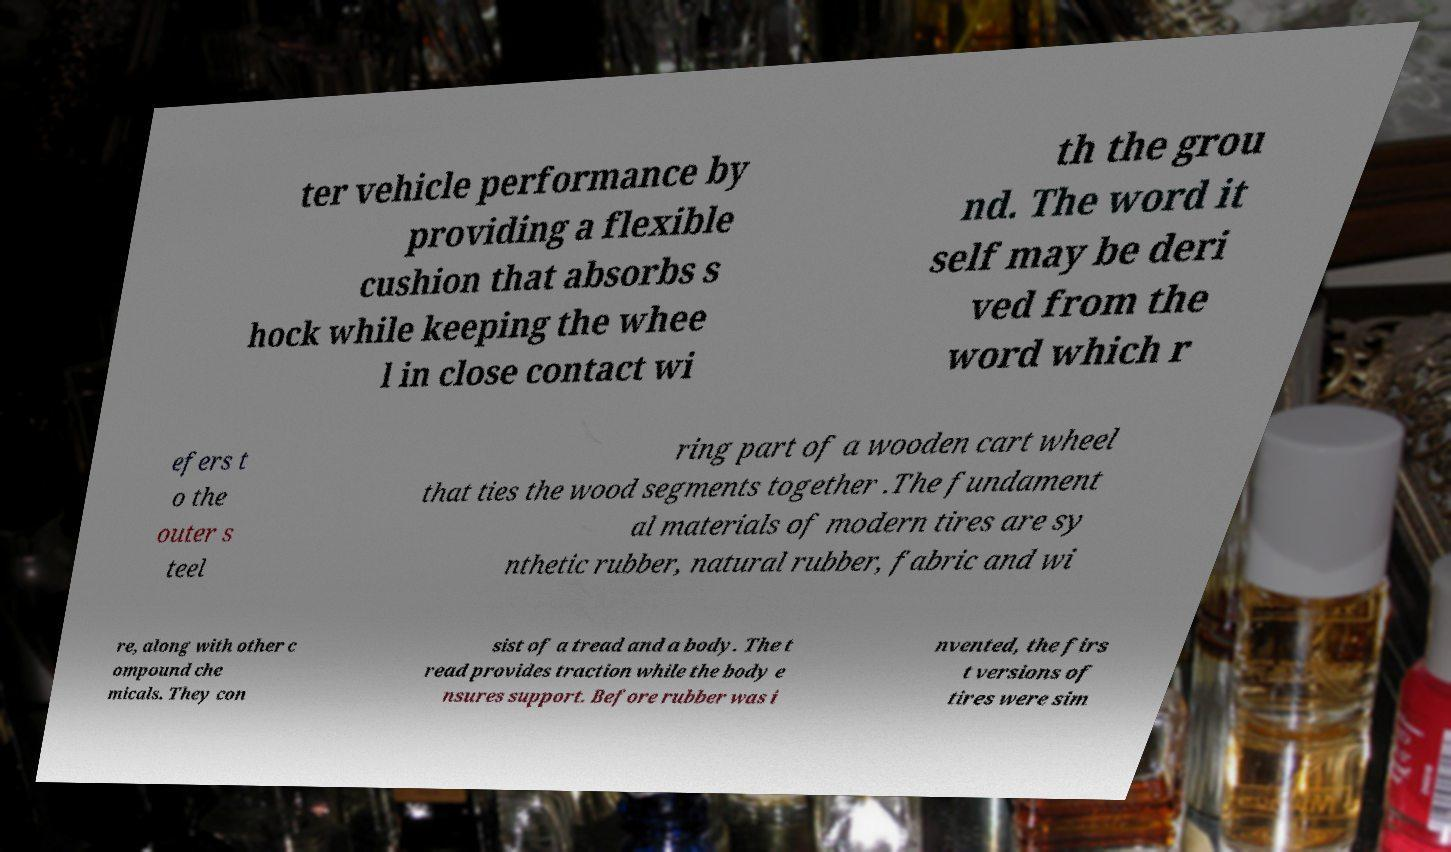Please read and relay the text visible in this image. What does it say? ter vehicle performance by providing a flexible cushion that absorbs s hock while keeping the whee l in close contact wi th the grou nd. The word it self may be deri ved from the word which r efers t o the outer s teel ring part of a wooden cart wheel that ties the wood segments together .The fundament al materials of modern tires are sy nthetic rubber, natural rubber, fabric and wi re, along with other c ompound che micals. They con sist of a tread and a body. The t read provides traction while the body e nsures support. Before rubber was i nvented, the firs t versions of tires were sim 